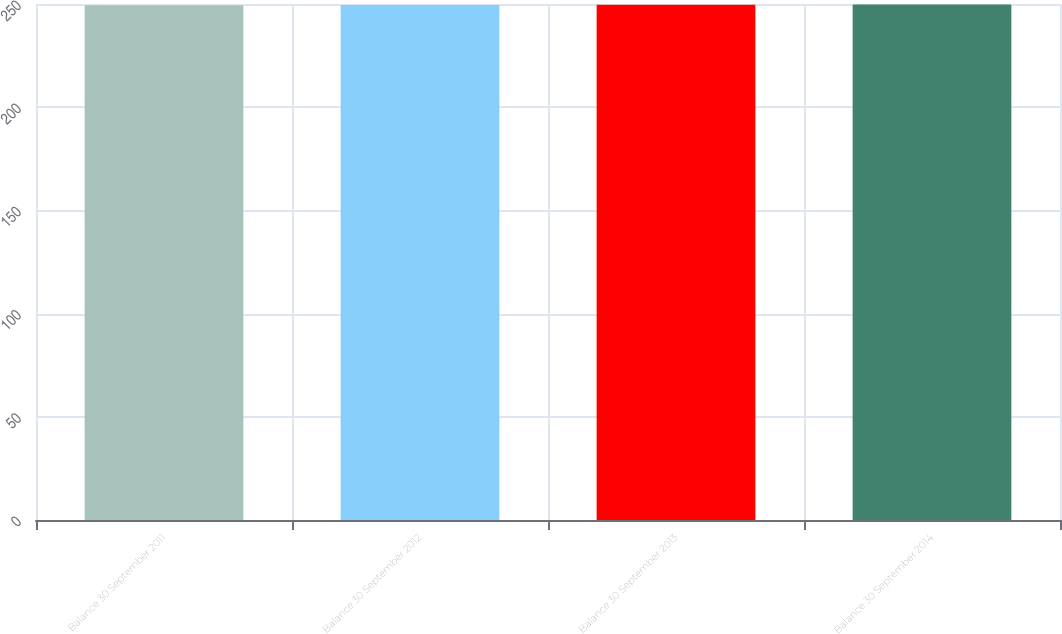<chart> <loc_0><loc_0><loc_500><loc_500><bar_chart><fcel>Balance 30 September 2011<fcel>Balance 30 September 2012<fcel>Balance 30 September 2013<fcel>Balance 30 September 2014<nl><fcel>249.4<fcel>249.5<fcel>249.6<fcel>249.7<nl></chart> 